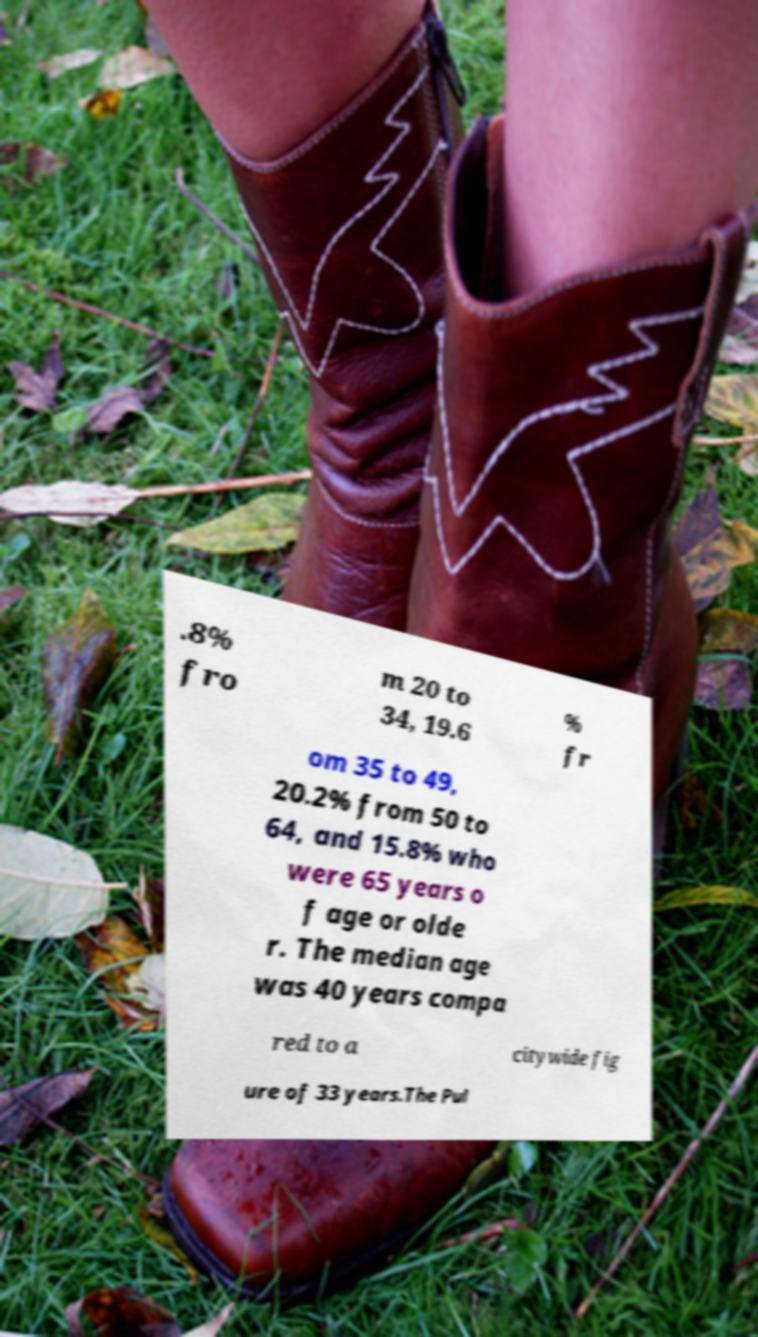Can you accurately transcribe the text from the provided image for me? .8% fro m 20 to 34, 19.6 % fr om 35 to 49, 20.2% from 50 to 64, and 15.8% who were 65 years o f age or olde r. The median age was 40 years compa red to a citywide fig ure of 33 years.The Pul 